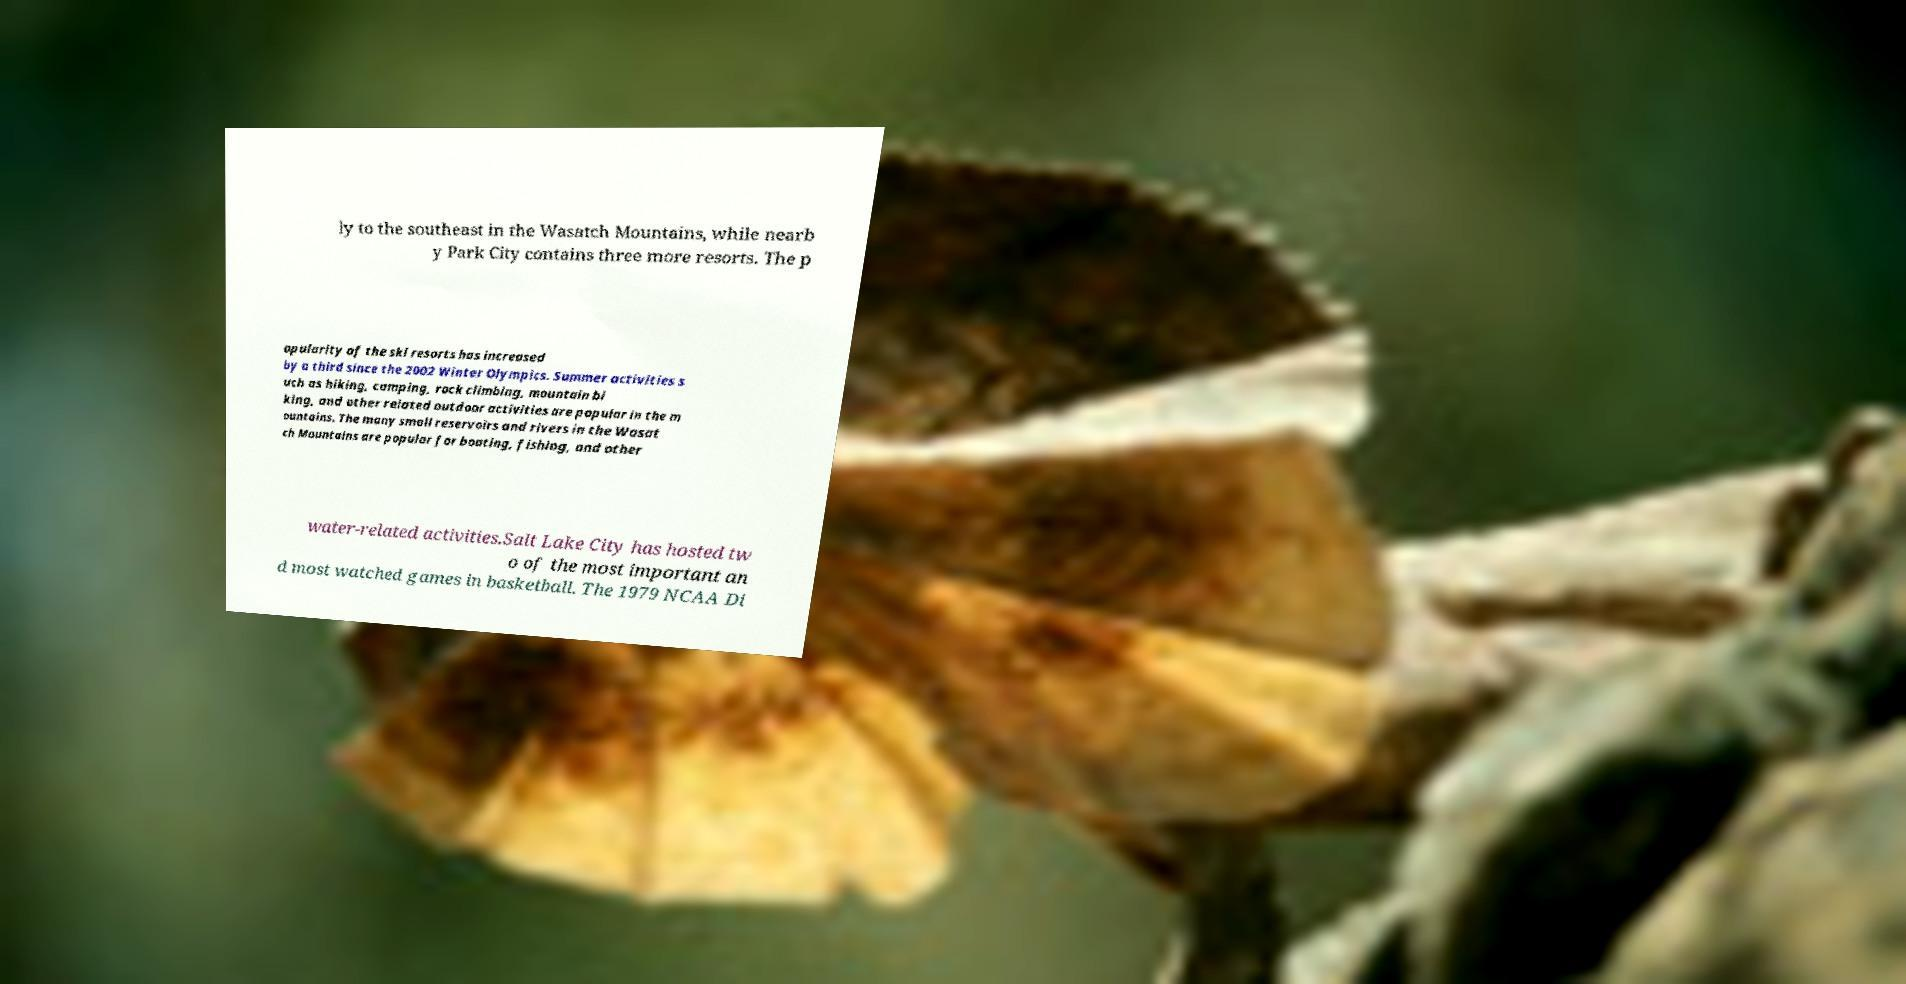Could you extract and type out the text from this image? ly to the southeast in the Wasatch Mountains, while nearb y Park City contains three more resorts. The p opularity of the ski resorts has increased by a third since the 2002 Winter Olympics. Summer activities s uch as hiking, camping, rock climbing, mountain bi king, and other related outdoor activities are popular in the m ountains. The many small reservoirs and rivers in the Wasat ch Mountains are popular for boating, fishing, and other water-related activities.Salt Lake City has hosted tw o of the most important an d most watched games in basketball. The 1979 NCAA Di 